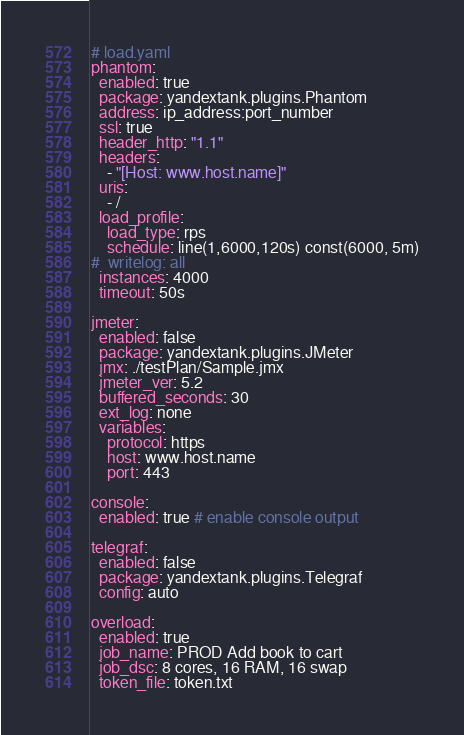<code> <loc_0><loc_0><loc_500><loc_500><_YAML_># load.yaml
phantom:
  enabled: true
  package: yandextank.plugins.Phantom
  address: ip_address:port_number
  ssl: true
  header_http: "1.1"
  headers:
    - "[Host: www.host.name]"
  uris:
    - /
  load_profile:
    load_type: rps
    schedule: line(1,6000,120s) const(6000, 5m)
#  writelog: all
  instances: 4000
  timeout: 50s
  
jmeter:
  enabled: false
  package: yandextank.plugins.JMeter
  jmx: ./testPlan/Sample.jmx
  jmeter_ver: 5.2
  buffered_seconds: 30
  ext_log: none
  variables:
    protocol: https
    host: www.host.name
    port: 443

console:
  enabled: true # enable console output

telegraf:
  enabled: false
  package: yandextank.plugins.Telegraf
  config: auto

overload:
  enabled: true
  job_name: PROD Add book to cart
  job_dsc: 8 cores, 16 RAM, 16 swap
  token_file: token.txt
</code> 